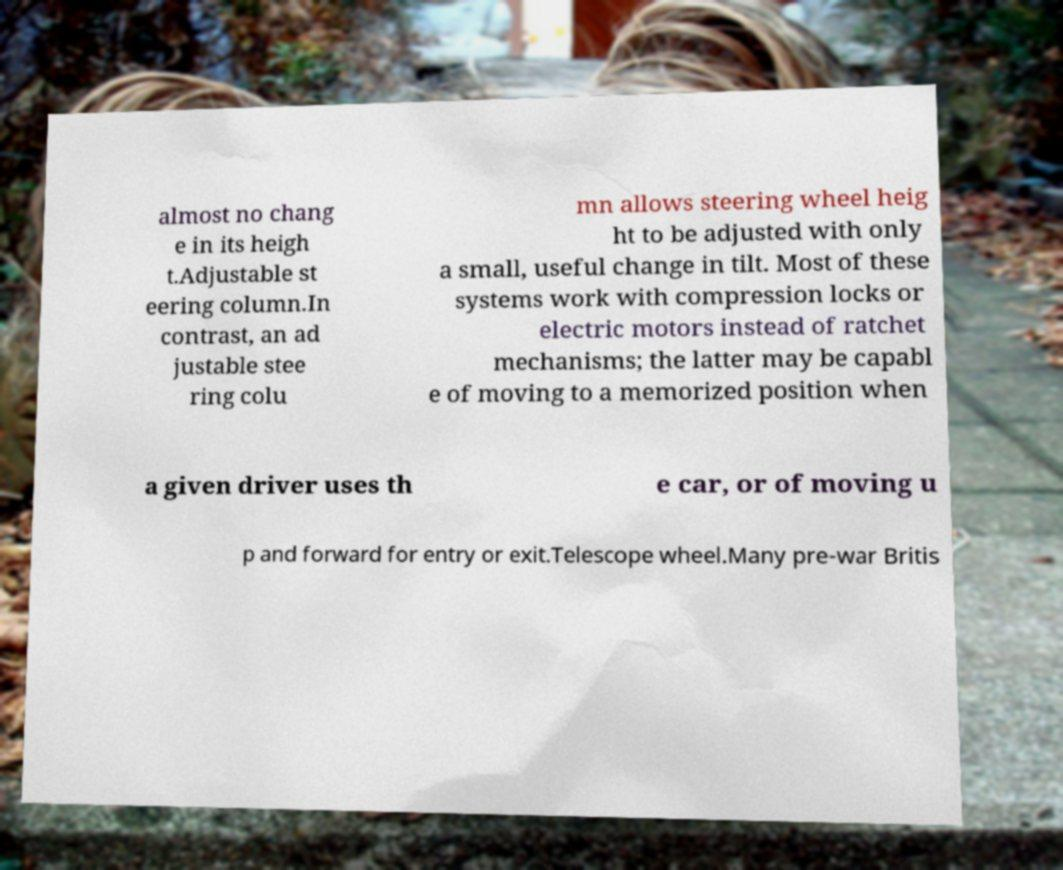Can you read and provide the text displayed in the image?This photo seems to have some interesting text. Can you extract and type it out for me? almost no chang e in its heigh t.Adjustable st eering column.In contrast, an ad justable stee ring colu mn allows steering wheel heig ht to be adjusted with only a small, useful change in tilt. Most of these systems work with compression locks or electric motors instead of ratchet mechanisms; the latter may be capabl e of moving to a memorized position when a given driver uses th e car, or of moving u p and forward for entry or exit.Telescope wheel.Many pre-war Britis 